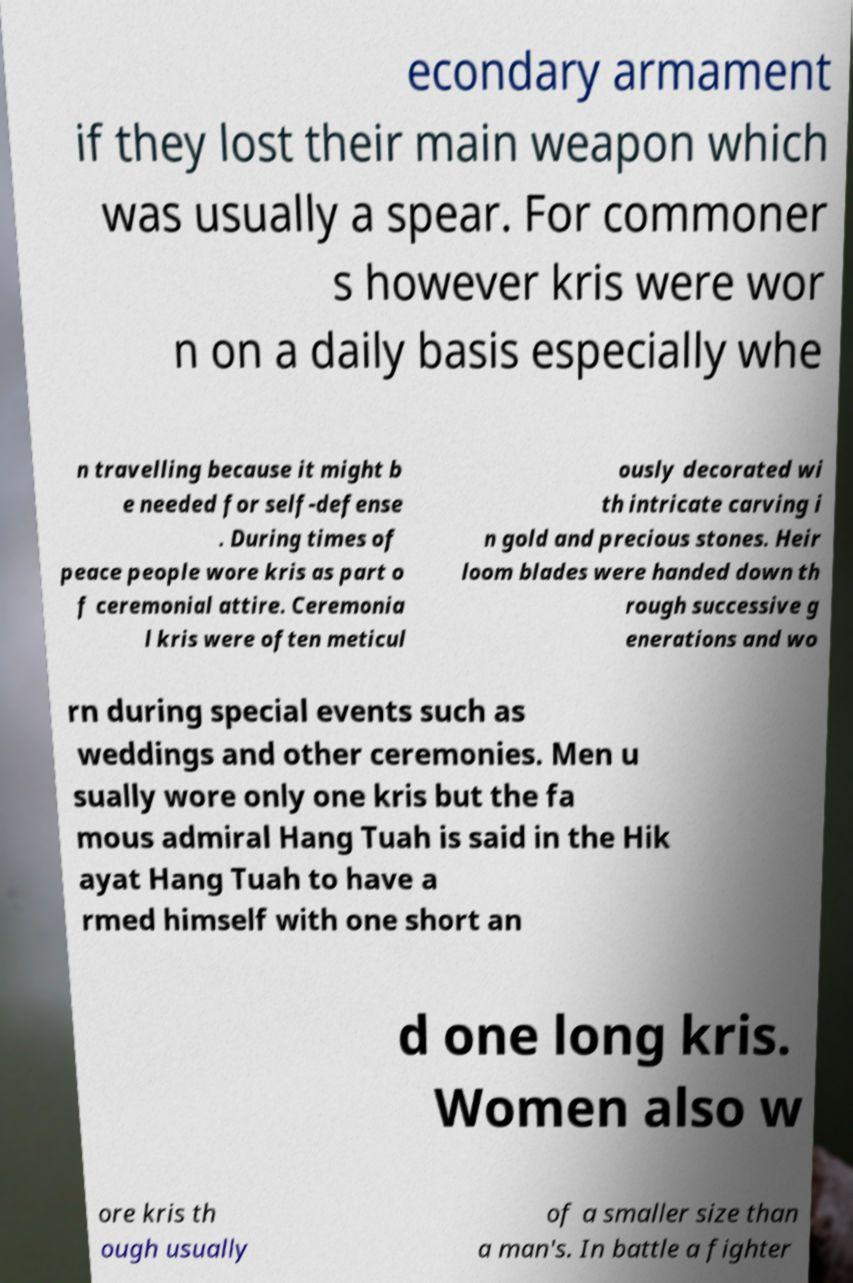Please identify and transcribe the text found in this image. econdary armament if they lost their main weapon which was usually a spear. For commoner s however kris were wor n on a daily basis especially whe n travelling because it might b e needed for self-defense . During times of peace people wore kris as part o f ceremonial attire. Ceremonia l kris were often meticul ously decorated wi th intricate carving i n gold and precious stones. Heir loom blades were handed down th rough successive g enerations and wo rn during special events such as weddings and other ceremonies. Men u sually wore only one kris but the fa mous admiral Hang Tuah is said in the Hik ayat Hang Tuah to have a rmed himself with one short an d one long kris. Women also w ore kris th ough usually of a smaller size than a man's. In battle a fighter 